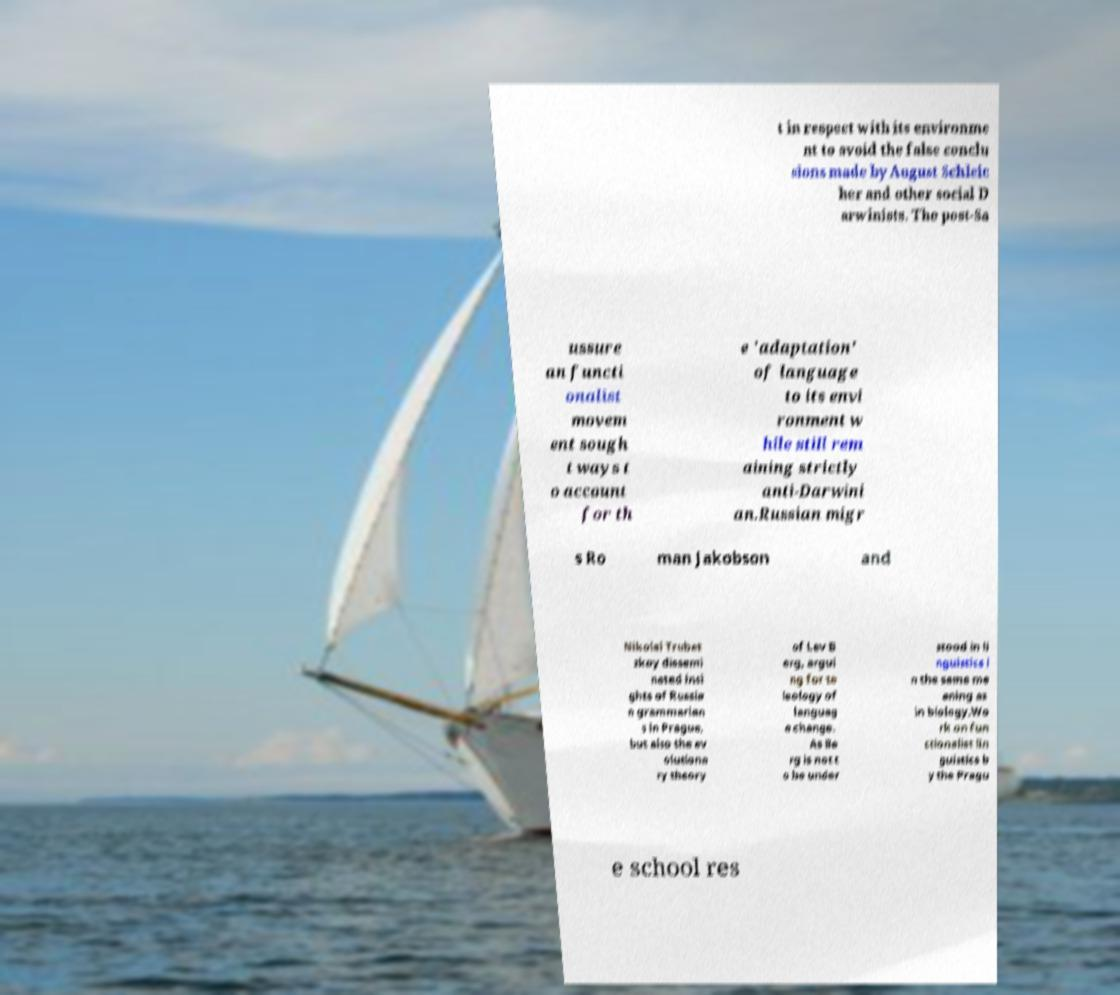Can you accurately transcribe the text from the provided image for me? t in respect with its environme nt to avoid the false conclu sions made by August Schleic her and other social D arwinists. The post-Sa ussure an functi onalist movem ent sough t ways t o account for th e 'adaptation' of language to its envi ronment w hile still rem aining strictly anti-Darwini an.Russian migr s Ro man Jakobson and Nikolai Trubet zkoy dissemi nated insi ghts of Russia n grammarian s in Prague, but also the ev olutiona ry theory of Lev B erg, argui ng for te leology of languag e change. As Be rg is not t o be under stood in li nguistics i n the same me aning as in biology.Wo rk on fun ctionalist lin guistics b y the Pragu e school res 